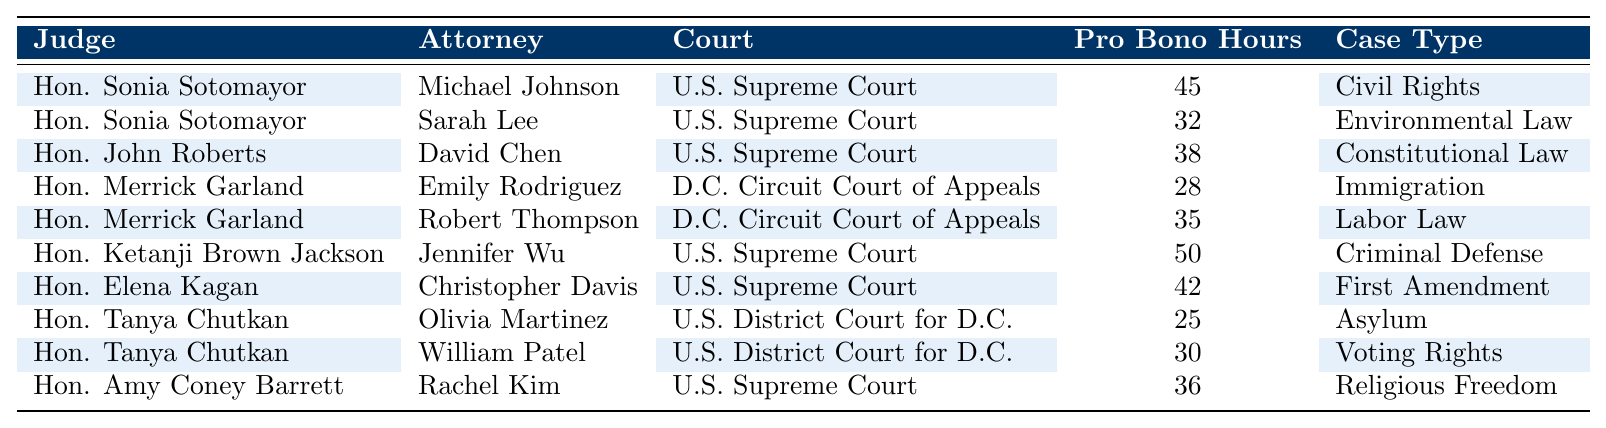What is the highest number of pro bono hours recorded for a single attorney in the table? By scanning the "Pro Bono Hours" column, I can see that Jennifer Wu has recorded the highest number at 50 hours.
Answer: 50 Which judge has the second-highest total of pro bono hours recorded by their attorneys? The total hours for each judge can be summed: Hon. Sonia Sotomayor (45 + 32 = 77), Hon. Merrick Garland (28 + 35 = 63), Hon. Ketanji Brown Jackson (50), Hon. Elena Kagan (42), Hon. Tanya Chutkan (25 + 30 = 55), Hon. Amy Coney Barrett (36). The second-highest is Hon. Sonia Sotomayor with 77 hours.
Answer: Hon. Sonia Sotomayor How many attorneys recorded pro bono hours in the district court for D.C.? By examining the "Court" column, I see two attorneys: Olivia Martinez and William Patel have recorded pro bono hours for the U.S. District Court for D.C.
Answer: 2 What case type had the lowest recorded pro bono hours and how many were there? Looking through the "Pro Bono Hours" column, the lowest value is 25 hours, recorded in the case type "Asylum."
Answer: Asylum, 25 Is there an attorney who recorded more than 40 pro bono hours? Checking the "Pro Bono Hours" column, I find that Michael Johnson (45), Jennifer Wu (50), and Christopher Davis (42) all have more than 40 hours recorded.
Answer: Yes What is the average number of pro bono hours recorded by attorneys for judges in the U.S. Supreme Court? The pro bono hours for U.S. Supreme Court attorneys are: 45, 32, 38, 50, 42, 36. The total sum is 243, and there are 6 attorneys, so the average is 243 / 6 = 40.5.
Answer: 40.5 Which judge has the most case types represented by pro bono hours? Counting the case types per judge: Hon. Sonia Sotomayor (2), Hon. Merrick Garland (2), Hon. Ketanji Brown Jackson (1), Hon. Elena Kagan (1), Hon. Tanya Chutkan (2), and Hon. Amy Coney Barrett (1). The maximum is 2, shared by Hon. Sonia Sotomayor, Hon. Merrick Garland, and Hon. Tanya Chutkan.
Answer: Hon. Sonia Sotomayor, Hon. Merrick Garland, and Hon. Tanya Chutkan What is the total pro bono hours recorded for all judges in immigration cases? The only immigration case listed is the one by Emily Rodriguez under Hon. Merrick Garland with 28 hours. Therefore, the total is 28 hours.
Answer: 28 Determine if "Voting Rights" is a case type listed in the table and which judge it is associated with. By scanning the "Case Type" column, "Voting Rights" is indeed present and is associated with Hon. Tanya Chutkan.
Answer: Yes, Hon. Tanya Chutkan If the pro bono hours for "Environmental Law" were to be doubled, what would the new total hours be for that case type? The current hours for "Environmental Law" are 32, so doubling it would give 32 * 2 = 64.
Answer: 64 